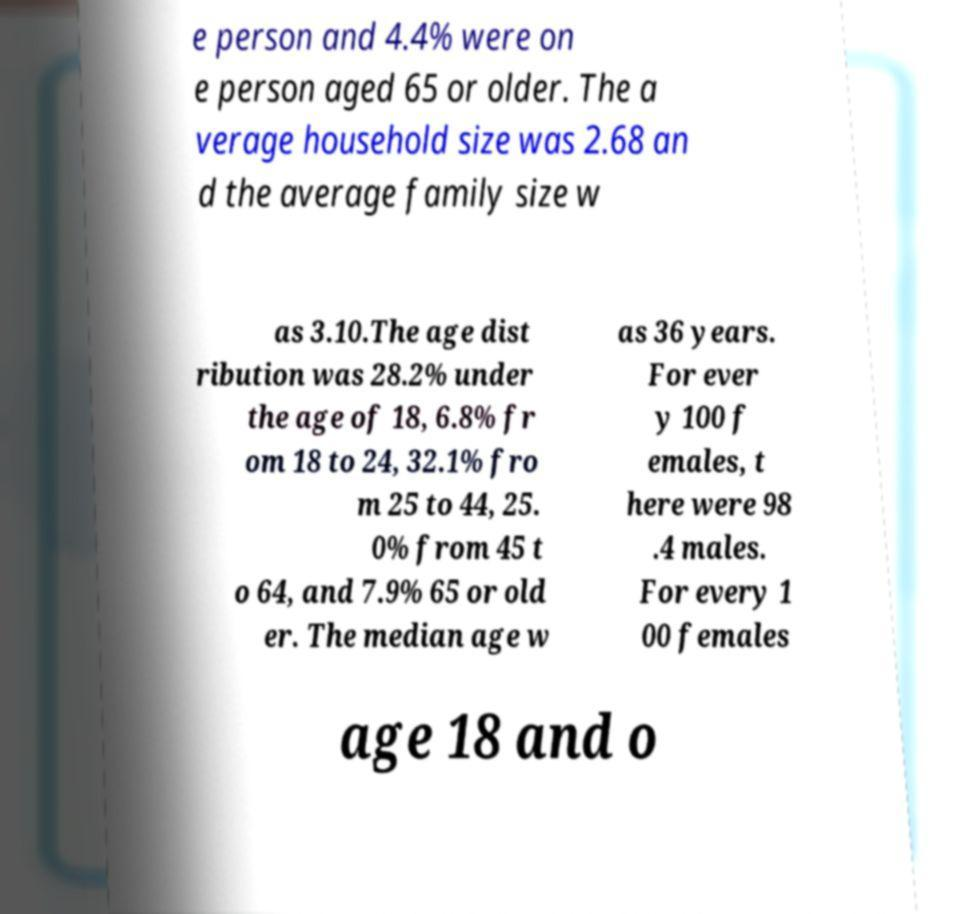Can you accurately transcribe the text from the provided image for me? e person and 4.4% were on e person aged 65 or older. The a verage household size was 2.68 an d the average family size w as 3.10.The age dist ribution was 28.2% under the age of 18, 6.8% fr om 18 to 24, 32.1% fro m 25 to 44, 25. 0% from 45 t o 64, and 7.9% 65 or old er. The median age w as 36 years. For ever y 100 f emales, t here were 98 .4 males. For every 1 00 females age 18 and o 